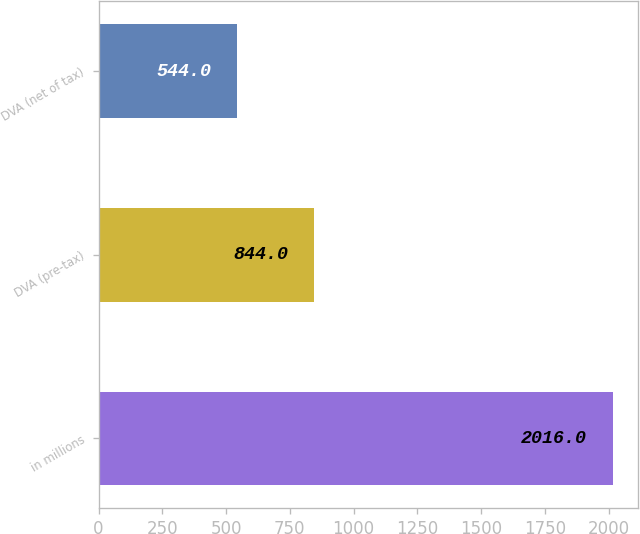Convert chart to OTSL. <chart><loc_0><loc_0><loc_500><loc_500><bar_chart><fcel>in millions<fcel>DVA (pre-tax)<fcel>DVA (net of tax)<nl><fcel>2016<fcel>844<fcel>544<nl></chart> 